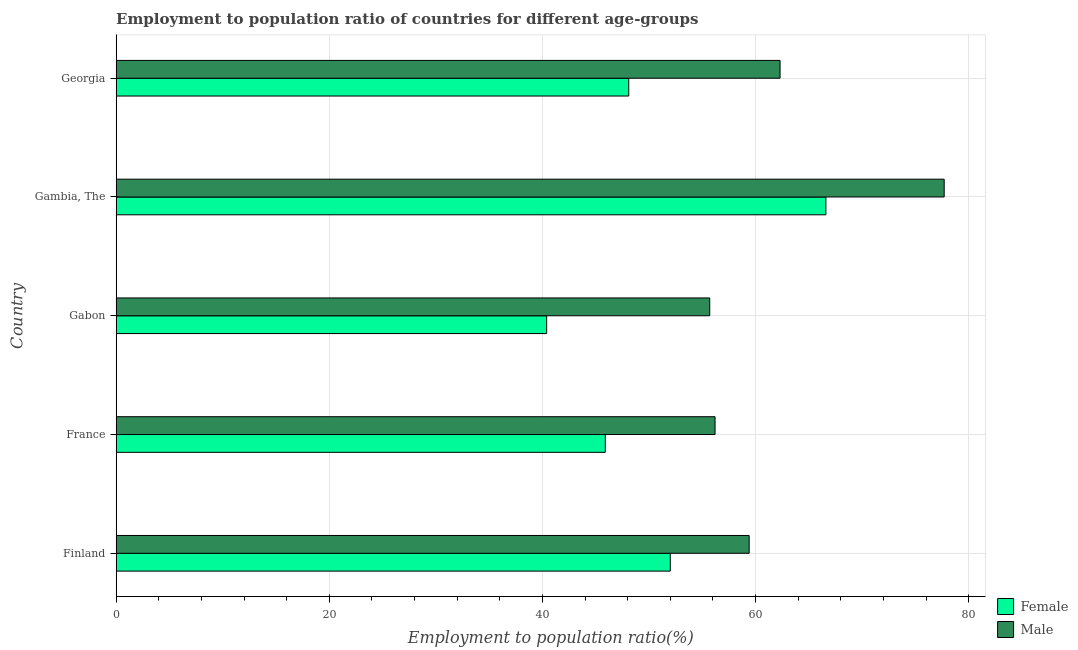How many groups of bars are there?
Offer a very short reply. 5. How many bars are there on the 2nd tick from the top?
Provide a succinct answer. 2. How many bars are there on the 3rd tick from the bottom?
Give a very brief answer. 2. What is the label of the 3rd group of bars from the top?
Your answer should be very brief. Gabon. What is the employment to population ratio(female) in Gambia, The?
Your answer should be compact. 66.6. Across all countries, what is the maximum employment to population ratio(male)?
Give a very brief answer. 77.7. Across all countries, what is the minimum employment to population ratio(female)?
Offer a terse response. 40.4. In which country was the employment to population ratio(male) maximum?
Give a very brief answer. Gambia, The. In which country was the employment to population ratio(female) minimum?
Offer a terse response. Gabon. What is the total employment to population ratio(male) in the graph?
Your answer should be compact. 311.3. What is the difference between the employment to population ratio(female) in Finland and that in Gambia, The?
Offer a very short reply. -14.6. What is the average employment to population ratio(female) per country?
Keep it short and to the point. 50.6. In how many countries, is the employment to population ratio(male) greater than 52 %?
Offer a very short reply. 5. What is the ratio of the employment to population ratio(female) in Finland to that in Georgia?
Your response must be concise. 1.08. Is the difference between the employment to population ratio(female) in Finland and Gambia, The greater than the difference between the employment to population ratio(male) in Finland and Gambia, The?
Keep it short and to the point. Yes. What is the difference between the highest and the lowest employment to population ratio(female)?
Ensure brevity in your answer.  26.2. What does the 2nd bar from the top in Gambia, The represents?
Your answer should be compact. Female. Are all the bars in the graph horizontal?
Give a very brief answer. Yes. How many countries are there in the graph?
Your answer should be compact. 5. Does the graph contain any zero values?
Make the answer very short. No. Does the graph contain grids?
Keep it short and to the point. Yes. Where does the legend appear in the graph?
Ensure brevity in your answer.  Bottom right. How many legend labels are there?
Your answer should be compact. 2. What is the title of the graph?
Offer a very short reply. Employment to population ratio of countries for different age-groups. Does "Diarrhea" appear as one of the legend labels in the graph?
Offer a very short reply. No. What is the Employment to population ratio(%) of Female in Finland?
Your response must be concise. 52. What is the Employment to population ratio(%) in Male in Finland?
Make the answer very short. 59.4. What is the Employment to population ratio(%) of Female in France?
Make the answer very short. 45.9. What is the Employment to population ratio(%) of Male in France?
Offer a very short reply. 56.2. What is the Employment to population ratio(%) of Female in Gabon?
Ensure brevity in your answer.  40.4. What is the Employment to population ratio(%) in Male in Gabon?
Your answer should be compact. 55.7. What is the Employment to population ratio(%) of Female in Gambia, The?
Your answer should be very brief. 66.6. What is the Employment to population ratio(%) in Male in Gambia, The?
Offer a terse response. 77.7. What is the Employment to population ratio(%) in Female in Georgia?
Your answer should be compact. 48.1. What is the Employment to population ratio(%) in Male in Georgia?
Your answer should be compact. 62.3. Across all countries, what is the maximum Employment to population ratio(%) of Female?
Make the answer very short. 66.6. Across all countries, what is the maximum Employment to population ratio(%) of Male?
Ensure brevity in your answer.  77.7. Across all countries, what is the minimum Employment to population ratio(%) of Female?
Ensure brevity in your answer.  40.4. Across all countries, what is the minimum Employment to population ratio(%) of Male?
Ensure brevity in your answer.  55.7. What is the total Employment to population ratio(%) of Female in the graph?
Your answer should be compact. 253. What is the total Employment to population ratio(%) of Male in the graph?
Make the answer very short. 311.3. What is the difference between the Employment to population ratio(%) of Male in Finland and that in France?
Your answer should be very brief. 3.2. What is the difference between the Employment to population ratio(%) of Female in Finland and that in Gabon?
Your answer should be compact. 11.6. What is the difference between the Employment to population ratio(%) in Female in Finland and that in Gambia, The?
Provide a short and direct response. -14.6. What is the difference between the Employment to population ratio(%) in Male in Finland and that in Gambia, The?
Offer a terse response. -18.3. What is the difference between the Employment to population ratio(%) in Male in Finland and that in Georgia?
Keep it short and to the point. -2.9. What is the difference between the Employment to population ratio(%) in Male in France and that in Gabon?
Your answer should be very brief. 0.5. What is the difference between the Employment to population ratio(%) in Female in France and that in Gambia, The?
Your response must be concise. -20.7. What is the difference between the Employment to population ratio(%) of Male in France and that in Gambia, The?
Make the answer very short. -21.5. What is the difference between the Employment to population ratio(%) in Male in France and that in Georgia?
Offer a very short reply. -6.1. What is the difference between the Employment to population ratio(%) in Female in Gabon and that in Gambia, The?
Your response must be concise. -26.2. What is the difference between the Employment to population ratio(%) of Male in Gabon and that in Gambia, The?
Offer a terse response. -22. What is the difference between the Employment to population ratio(%) in Female in Gabon and that in Georgia?
Ensure brevity in your answer.  -7.7. What is the difference between the Employment to population ratio(%) in Female in Finland and the Employment to population ratio(%) in Male in France?
Keep it short and to the point. -4.2. What is the difference between the Employment to population ratio(%) in Female in Finland and the Employment to population ratio(%) in Male in Gabon?
Make the answer very short. -3.7. What is the difference between the Employment to population ratio(%) of Female in Finland and the Employment to population ratio(%) of Male in Gambia, The?
Make the answer very short. -25.7. What is the difference between the Employment to population ratio(%) in Female in France and the Employment to population ratio(%) in Male in Gambia, The?
Offer a very short reply. -31.8. What is the difference between the Employment to population ratio(%) of Female in France and the Employment to population ratio(%) of Male in Georgia?
Your answer should be compact. -16.4. What is the difference between the Employment to population ratio(%) in Female in Gabon and the Employment to population ratio(%) in Male in Gambia, The?
Provide a short and direct response. -37.3. What is the difference between the Employment to population ratio(%) in Female in Gabon and the Employment to population ratio(%) in Male in Georgia?
Ensure brevity in your answer.  -21.9. What is the difference between the Employment to population ratio(%) of Female in Gambia, The and the Employment to population ratio(%) of Male in Georgia?
Ensure brevity in your answer.  4.3. What is the average Employment to population ratio(%) in Female per country?
Keep it short and to the point. 50.6. What is the average Employment to population ratio(%) in Male per country?
Your answer should be compact. 62.26. What is the difference between the Employment to population ratio(%) of Female and Employment to population ratio(%) of Male in France?
Your response must be concise. -10.3. What is the difference between the Employment to population ratio(%) in Female and Employment to population ratio(%) in Male in Gabon?
Your answer should be compact. -15.3. What is the ratio of the Employment to population ratio(%) of Female in Finland to that in France?
Provide a succinct answer. 1.13. What is the ratio of the Employment to population ratio(%) of Male in Finland to that in France?
Make the answer very short. 1.06. What is the ratio of the Employment to population ratio(%) of Female in Finland to that in Gabon?
Your response must be concise. 1.29. What is the ratio of the Employment to population ratio(%) in Male in Finland to that in Gabon?
Your answer should be very brief. 1.07. What is the ratio of the Employment to population ratio(%) of Female in Finland to that in Gambia, The?
Offer a terse response. 0.78. What is the ratio of the Employment to population ratio(%) in Male in Finland to that in Gambia, The?
Provide a short and direct response. 0.76. What is the ratio of the Employment to population ratio(%) in Female in Finland to that in Georgia?
Ensure brevity in your answer.  1.08. What is the ratio of the Employment to population ratio(%) of Male in Finland to that in Georgia?
Provide a succinct answer. 0.95. What is the ratio of the Employment to population ratio(%) of Female in France to that in Gabon?
Your answer should be compact. 1.14. What is the ratio of the Employment to population ratio(%) of Female in France to that in Gambia, The?
Your answer should be compact. 0.69. What is the ratio of the Employment to population ratio(%) of Male in France to that in Gambia, The?
Ensure brevity in your answer.  0.72. What is the ratio of the Employment to population ratio(%) of Female in France to that in Georgia?
Keep it short and to the point. 0.95. What is the ratio of the Employment to population ratio(%) in Male in France to that in Georgia?
Your answer should be very brief. 0.9. What is the ratio of the Employment to population ratio(%) of Female in Gabon to that in Gambia, The?
Offer a terse response. 0.61. What is the ratio of the Employment to population ratio(%) of Male in Gabon to that in Gambia, The?
Provide a succinct answer. 0.72. What is the ratio of the Employment to population ratio(%) in Female in Gabon to that in Georgia?
Provide a succinct answer. 0.84. What is the ratio of the Employment to population ratio(%) in Male in Gabon to that in Georgia?
Your response must be concise. 0.89. What is the ratio of the Employment to population ratio(%) in Female in Gambia, The to that in Georgia?
Offer a terse response. 1.38. What is the ratio of the Employment to population ratio(%) of Male in Gambia, The to that in Georgia?
Provide a succinct answer. 1.25. What is the difference between the highest and the second highest Employment to population ratio(%) of Female?
Give a very brief answer. 14.6. What is the difference between the highest and the lowest Employment to population ratio(%) of Female?
Your answer should be very brief. 26.2. What is the difference between the highest and the lowest Employment to population ratio(%) in Male?
Offer a very short reply. 22. 